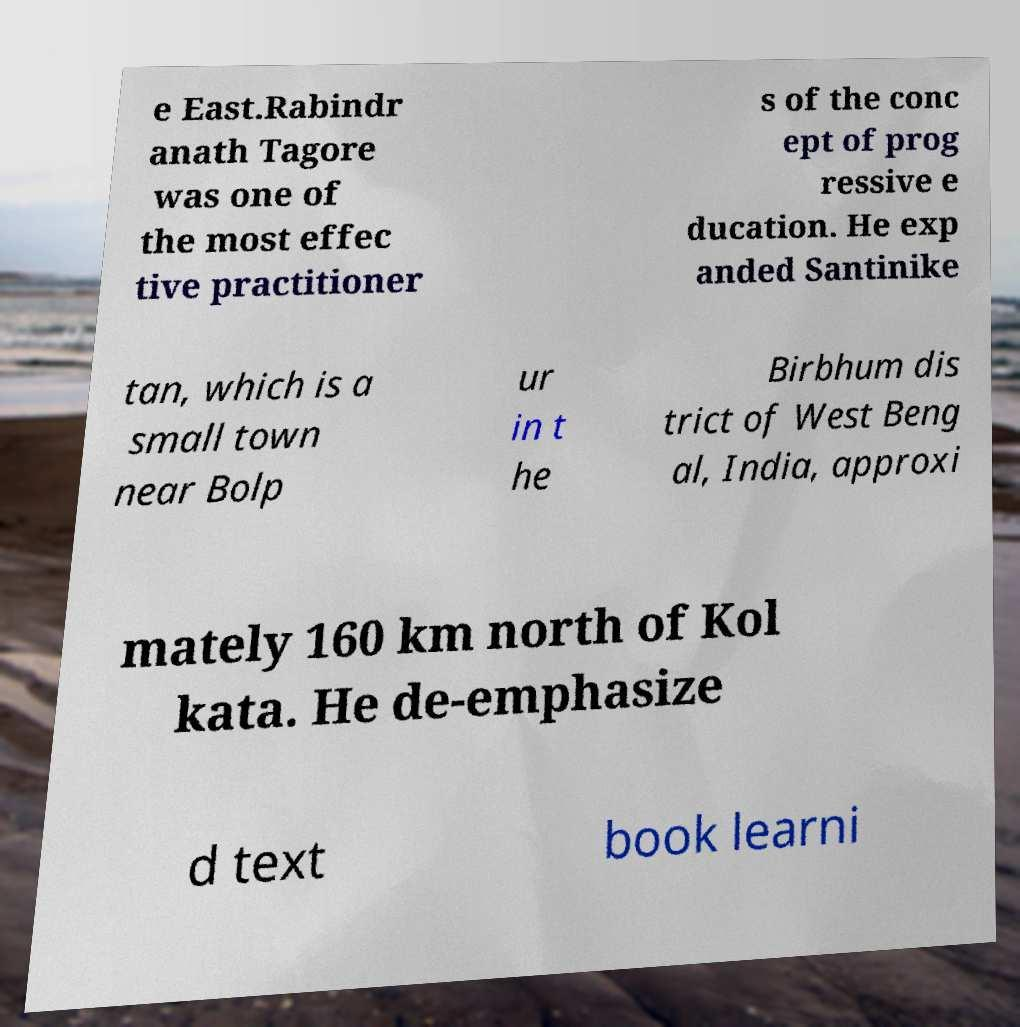There's text embedded in this image that I need extracted. Can you transcribe it verbatim? e East.Rabindr anath Tagore was one of the most effec tive practitioner s of the conc ept of prog ressive e ducation. He exp anded Santinike tan, which is a small town near Bolp ur in t he Birbhum dis trict of West Beng al, India, approxi mately 160 km north of Kol kata. He de-emphasize d text book learni 